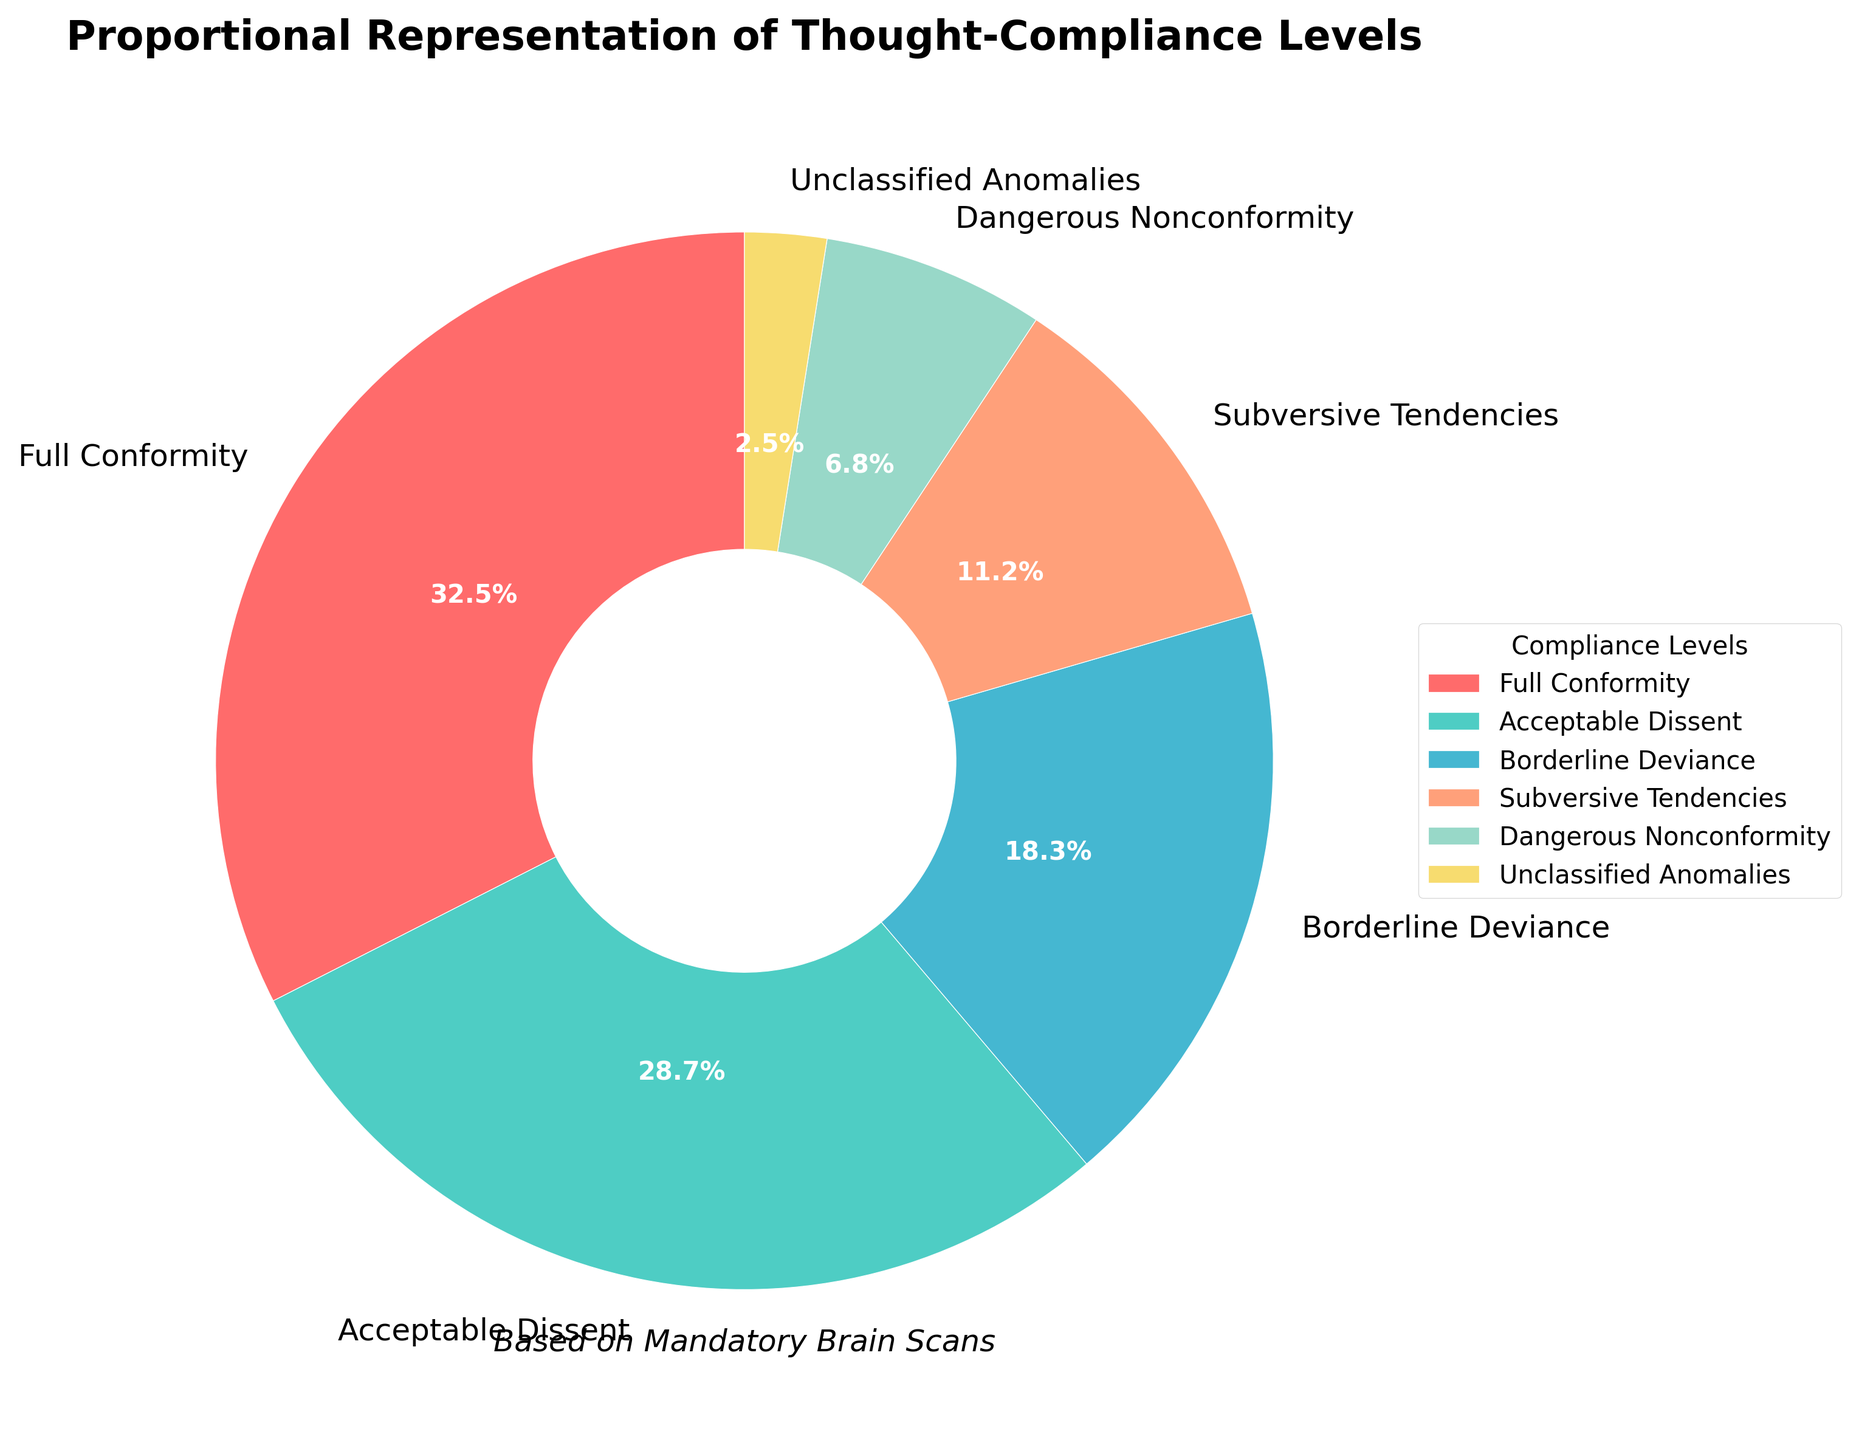What percentage of thought compliance is considered either Subversive Tendencies or Dangerous Nonconformity? To find the answer, sum the percentages of Subversive Tendencies (11.2%) and Dangerous Nonconformity (6.8%). 11.2 + 6.8 = 18.0
Answer: 18.0% Which thought-compliance level has the smallest representation? The level with the smallest percentage is Unclassified Anomalies at 2.5%.
Answer: Unclassified Anomalies How does the percentage of Borderline Deviance compare to Acceptable Dissent? Compare the percentages directly. Borderline Deviance is 18.3% and Acceptable Dissent is 28.7%, so Borderline Deviance is smaller.
Answer: Borderline Deviance is smaller What is the total percentage of compliance levels that are not full conformity? Subtract the percentage of Full Conformity (32.5%) from 100%. 100 - 32.5 = 67.5
Answer: 67.5% Which compliance level is represented by the color red? The Full Conformity section is colored red in the pie chart.
Answer: Full Conformity How much larger is Acceptable Dissent compared to Dangerous Nonconformity? Subtract the percentage of Dangerous Nonconformity (6.8%) from Acceptable Dissent (28.7%). 28.7 - 6.8 = 21.9
Answer: 21.9% Arrange the thought-compliance levels in descending order of their percentages. List the percentages from highest to lowest: Full Conformity (32.5%), Acceptable Dissent (28.7%), Borderline Deviance (18.3%), Subversive Tendencies (11.2%), Dangerous Nonconformity (6.8%), Unclassified Anomalies (2.5%).
Answer: Full Conformity, Acceptable Dissent, Borderline Deviance, Subversive Tendencies, Dangerous Nonconformity, Unclassified Anomalies What's the combined percentage of Full Conformity, Acceptable Dissent, and Borderline Deviance? Sum the percentages of Full Conformity (32.5%), Acceptable Dissent (28.7%), and Borderline Deviance (18.3%). 32.5 + 28.7 + 18.3 = 79.5
Answer: 79.5% 